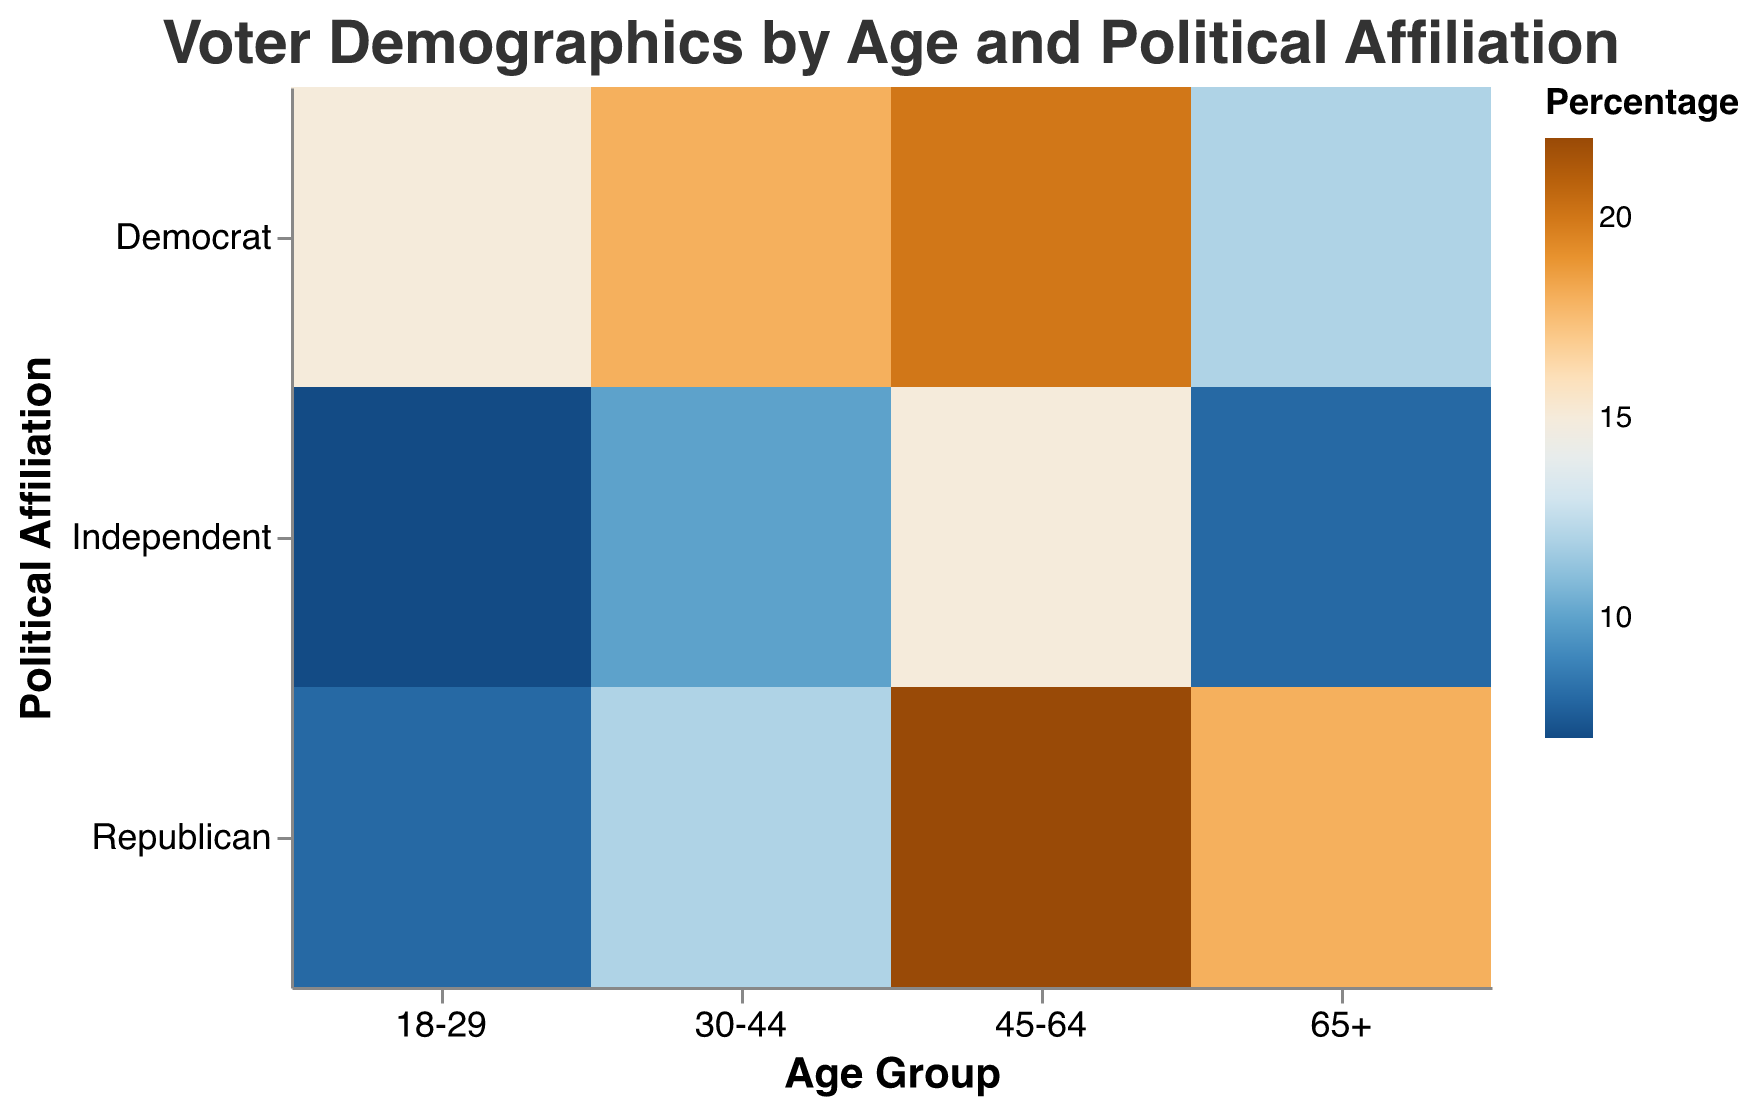What is the title of the mosaic plot? The title of the mosaic plot is typically found at the top of the plot and provides a summary of what the chart demonstrates. Here, the title is "Voter Demographics by Age and Political Affiliation."
Answer: Voter Demographics by Age and Political Affiliation How many age groups are displayed in the plot? By examining the x-axis, which represents age groups, you can see distinct categories labeled "18-29," "30-44," "45-64," and "65+."
Answer: 4 Which age group has the highest percentage of Democrat voters? Focus on the color and size of the rectangles representing Democrat voters within each age group. The "45-64" age group has the largest and darkest rectangle, indicating the highest percentage.
Answer: 45-64 What is the percentage of Republican voters in the 30-44 age group? Look for the rectangle corresponding to Republican voters in the "30-44" age group and check its color and size. The percentage listed for this group is 12.
Answer: 12 Which political affiliation shows the least variance across all age groups? Compare the variations in size and color of the rectangles for each political affiliation. "Independent" affiliation shows the least variance in percentages across all age groups.
Answer: Independent What is the combined percentage of Democrat and Independent voters in the 65+ age group? Add the percentage values for Democrat and Independent voters in the "65+" age group: 12 (Democrat) + 8 (Independent) = 20.
Answer: 20 Compare the percentage of Republican voters in the 18-29 age group with those in the 65+ age group. Which is higher? Check the percentage values for Republican voters in both the 18-29 (8) and 65+ (18) age groups and compare them. The 65+ group is higher.
Answer: 65+ How does the percentage of Independent voters in the 45-64 age group compare to Democrat voters in the same group? Look at the percentage values for both Independent (15) and Democrat (20) in the 45-64 age group and compare them. The percentage of Democrat voters is higher.
Answer: 20 is higher than 15 Which political affiliation has the highest percentage in the 45-64 age group, and what is that percentage? Examine the rectangles within the 45-64 age group and identify the one with the darkest color and largest size. Republican affiliation has the highest percentage, which is 22.
Answer: Republican, 22 